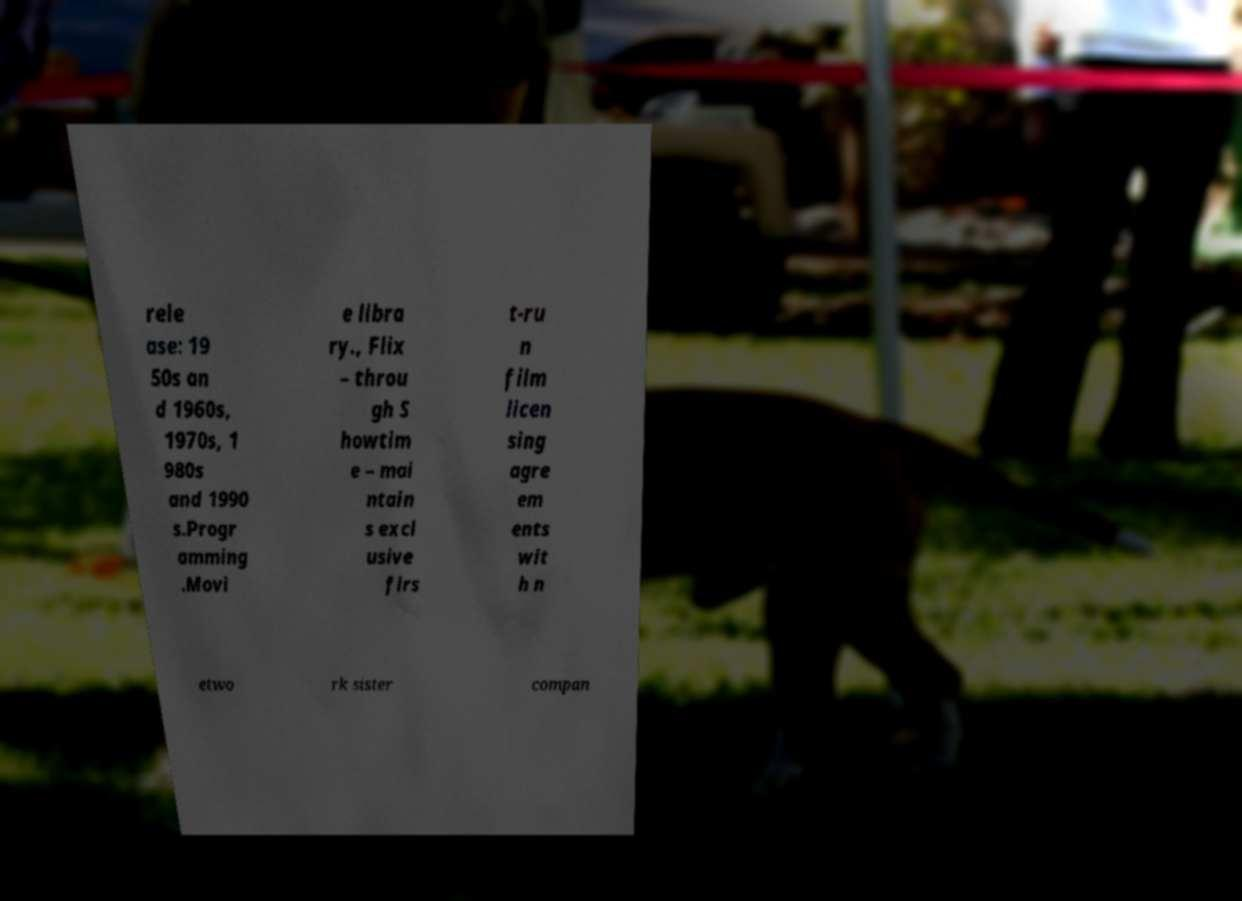Please read and relay the text visible in this image. What does it say? rele ase: 19 50s an d 1960s, 1970s, 1 980s and 1990 s.Progr amming .Movi e libra ry., Flix – throu gh S howtim e – mai ntain s excl usive firs t-ru n film licen sing agre em ents wit h n etwo rk sister compan 